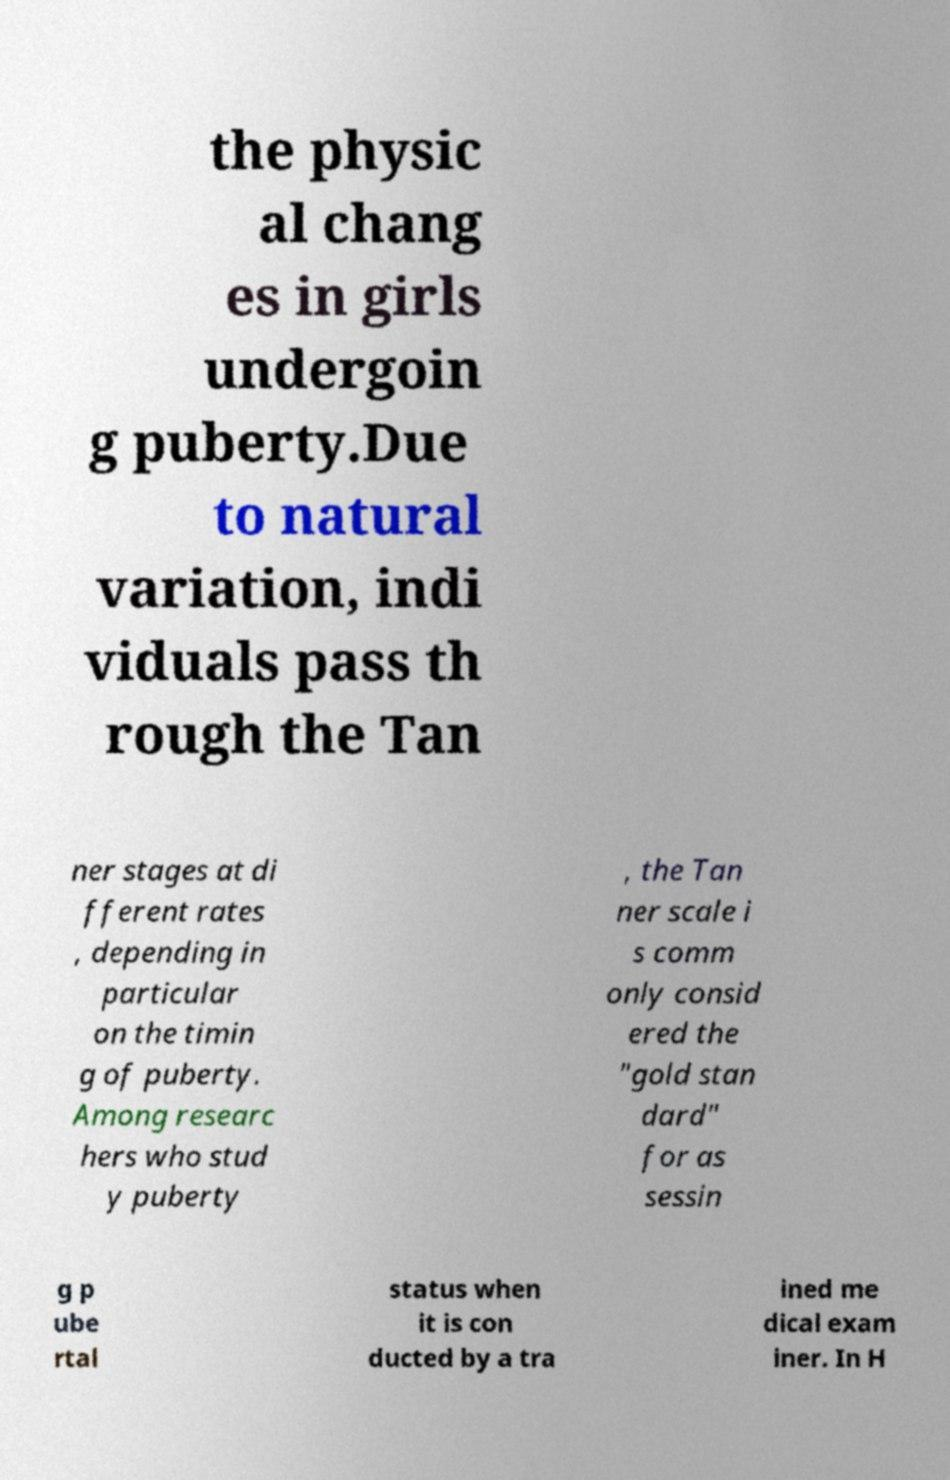There's text embedded in this image that I need extracted. Can you transcribe it verbatim? the physic al chang es in girls undergoin g puberty.Due to natural variation, indi viduals pass th rough the Tan ner stages at di fferent rates , depending in particular on the timin g of puberty. Among researc hers who stud y puberty , the Tan ner scale i s comm only consid ered the "gold stan dard" for as sessin g p ube rtal status when it is con ducted by a tra ined me dical exam iner. In H 